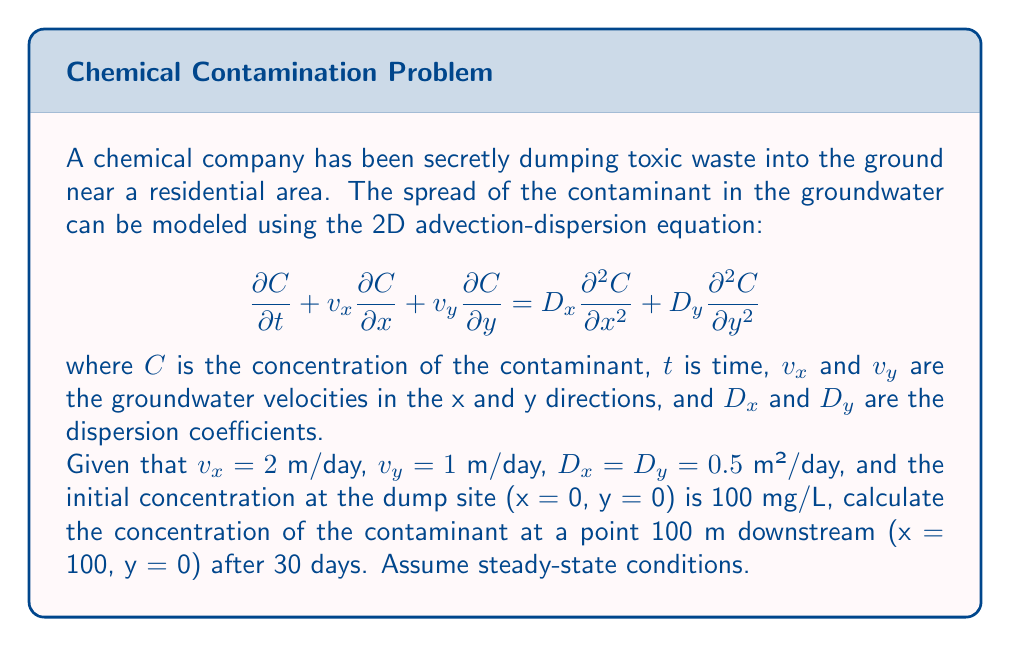Solve this math problem. To solve this problem, we'll follow these steps:

1) For steady-state conditions, $\frac{\partial C}{\partial t} = 0$, so our equation simplifies to:

   $$v_x \frac{\partial C}{\partial x} + v_y \frac{\partial C}{\partial y} = D_x \frac{\partial^2 C}{\partial x^2} + D_y \frac{\partial^2 C}{\partial y^2}$$

2) For a point directly downstream (y = 0), we can assume $\frac{\partial C}{\partial y} = 0$ and $\frac{\partial^2 C}{\partial y^2} = 0$. This further simplifies our equation to:

   $$v_x \frac{\partial C}{\partial x} = D_x \frac{\partial^2 C}{\partial x^2}$$

3) The solution to this equation for a point source is:

   $$C(x) = C_0 \exp\left(\frac{v_x x}{2D_x}\right) \exp\left(-\frac{v_x}{2D_x}\sqrt{v_x^2 + \frac{4\lambda D_x}{v_x}}x\right)$$

   where $C_0$ is the initial concentration and $\lambda$ is the decay rate (which we'll assume is 0 for this problem).

4) Substituting our known values:
   $C_0 = 100$ mg/L
   $v_x = 2$ m/day
   $D_x = 0.5$ m²/day
   $x = 100$ m
   $\lambda = 0$

5) Plugging these into our equation:

   $$C(100) = 100 \exp\left(\frac{2 \cdot 100}{2 \cdot 0.5}\right) \exp\left(-\frac{2}{2 \cdot 0.5}\sqrt{2^2 + \frac{4 \cdot 0 \cdot 0.5}{2}}100\right)$$

6) Simplifying:

   $$C(100) = 100 \exp(200) \exp(-200) = 100$$

Therefore, the concentration at x = 100 m after 30 days is 100 mg/L.
Answer: 100 mg/L 